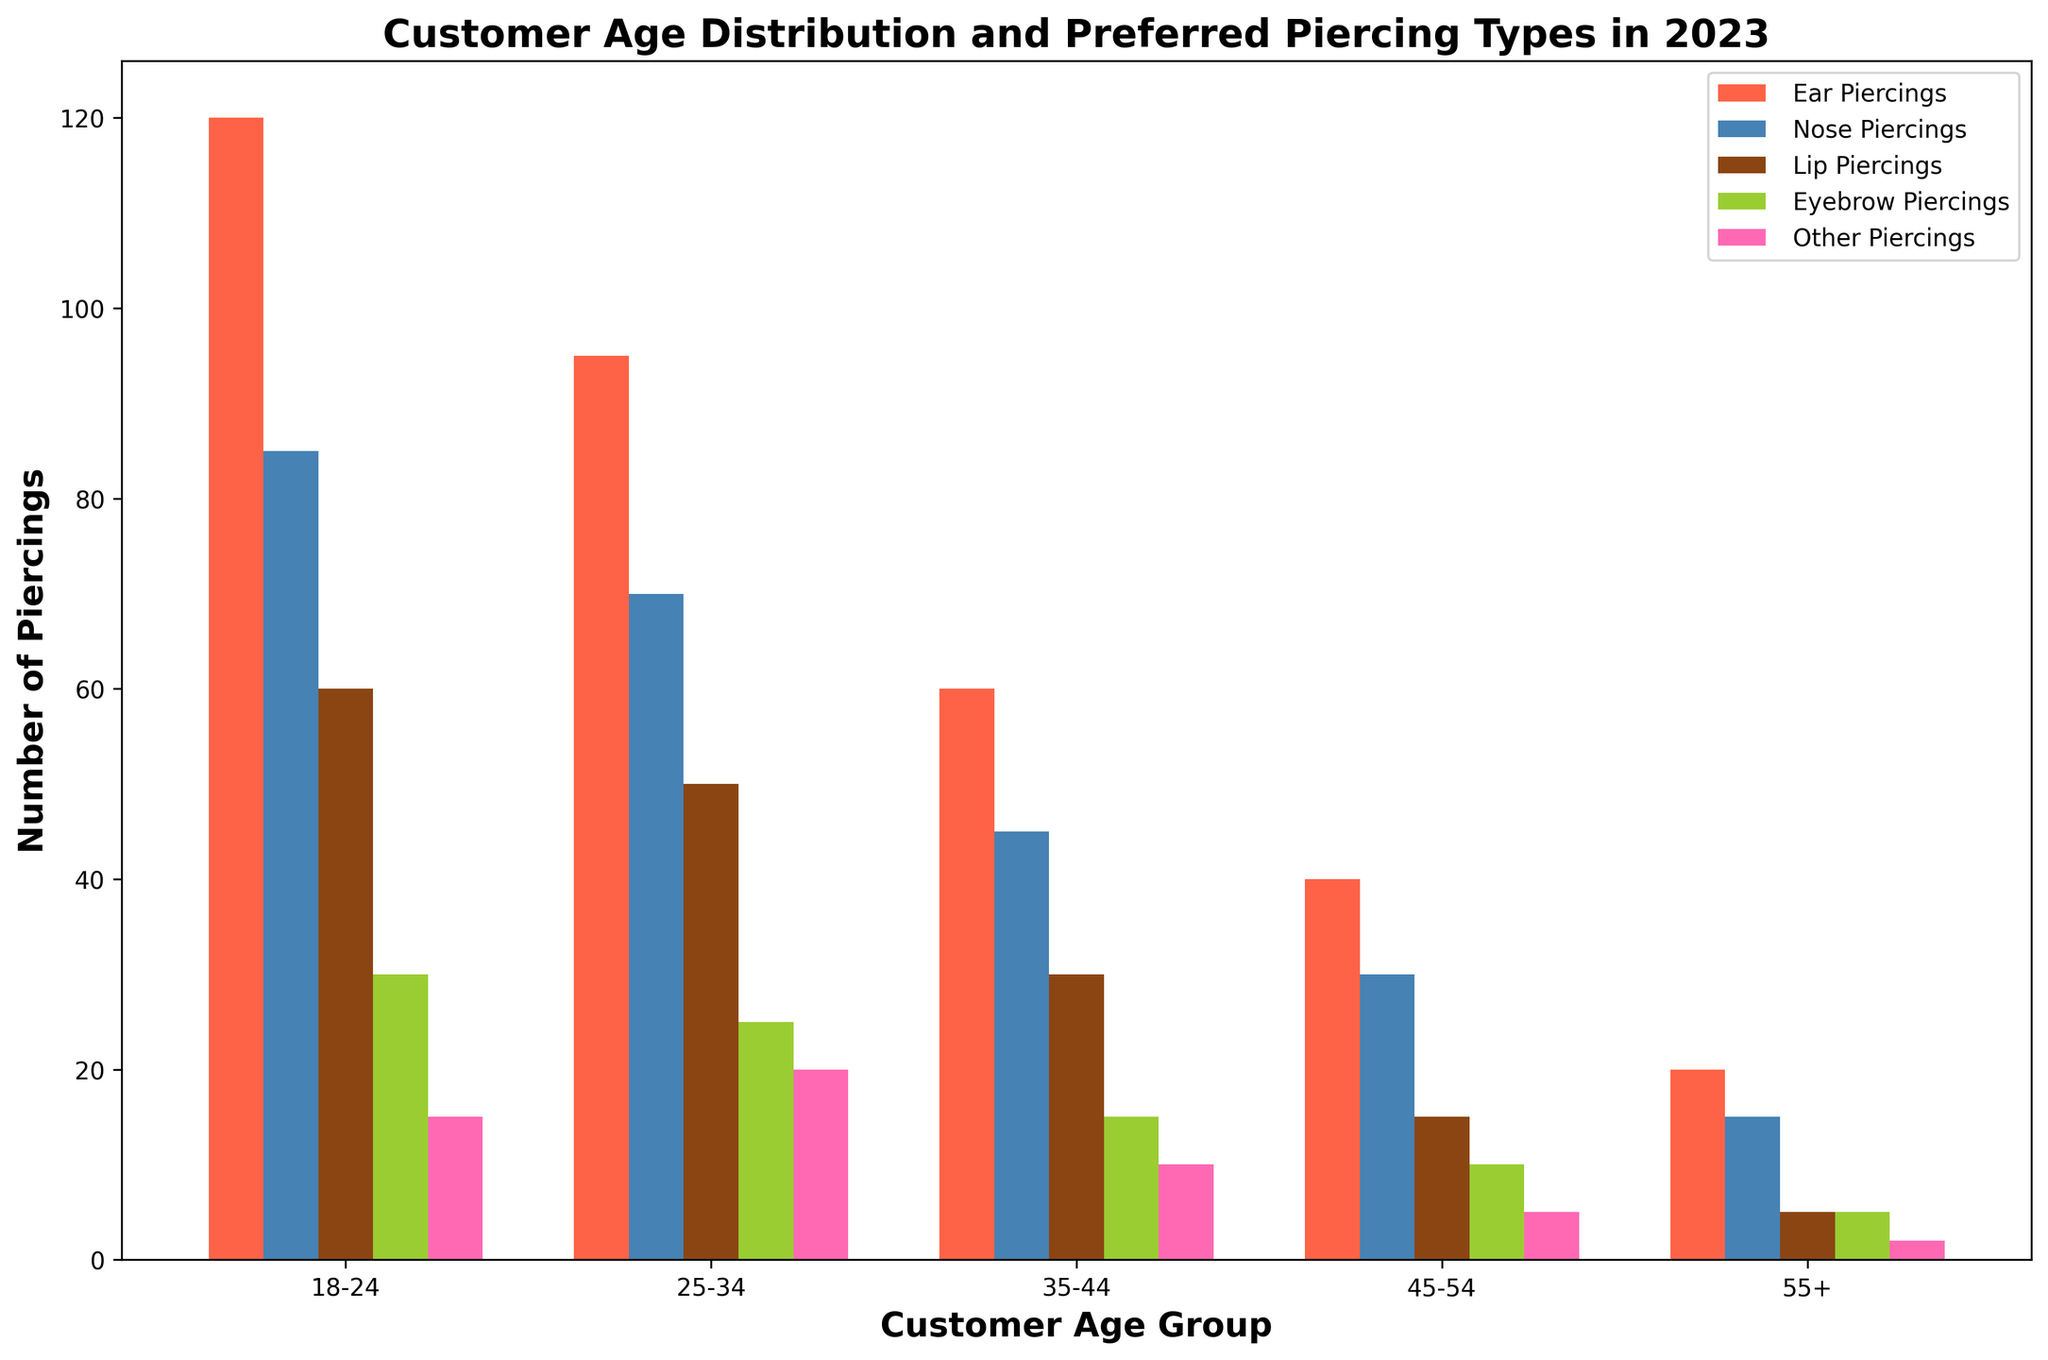Which age group has the highest number of ear piercings? To find the age group with the highest number of ear piercings, look at the bar representing ear piercings for each age group. The tallest bar represents the 18-24 age group.
Answer: 18-24 Which piercing type is most popular among customers aged 25-34? Check the heights of the grouped bars for the 25-34 age group. The tallest bar represents ear piercings.
Answer: Ear Piercings How does the number of nose piercings among those aged 18-24 compare to those aged 35-44? Compare the heights of the nose piercing bars for the 18-24 and 35-44 age groups. The 18-24 age group bar is taller.
Answer: Higher in 18-24 What is the total number of piercings for the 55+ age group? Sum all the piercing counts for the 55+ age group: 20 (ear) + 15 (nose) + 5 (lip) + 5 (eyebrow) + 2 (other).
Answer: 47 Which age group has the lowest popularity for eyebrow piercings? Compare the heights of the eyebrow piercing bars across all age groups. The bar for the 55+ age group is the shortest.
Answer: 55+ How does the proportion of ear piercings compare between the 18-24 and 45-54 age groups? Calculate the proportion of ear piercings for the 18-24 age group (120 out of 310 total) and 45-54 age group (40 out of 100 total), and compare them.
Answer: Higher in 18-24 Do customers aged 35-44 prefer nose piercings or lip piercings? Compare the heights of the nose piercing and lip piercing bars for the 35-44 age group. The nose piercing bar is higher.
Answer: Nose Piercings What is the average number of lip piercings across all age groups? Sum the numbers of lip piercings: 60 + 50 + 30 + 15 + 5 = 160. Divide by the number of age groups, which is 5.
Answer: 32 Compare the difference in the total number of piercings between the 18-24 and 25-34 age groups. Calculate the total number of piercings for each group: 120+85+60+30+15 = 310 for 18-24, and 95+70+50+25+20 = 260 for 25-34. Subtract to find the difference.
Answer: 50 What piercing type is equally popular among the 45-54 and 55+ age groups? Compare the heights of the bars for each piercing type in the 45-54 and 55+ age groups. The eyebrow piercing bars are of equal height (10+10).
Answer: Eyebrow Piercings 